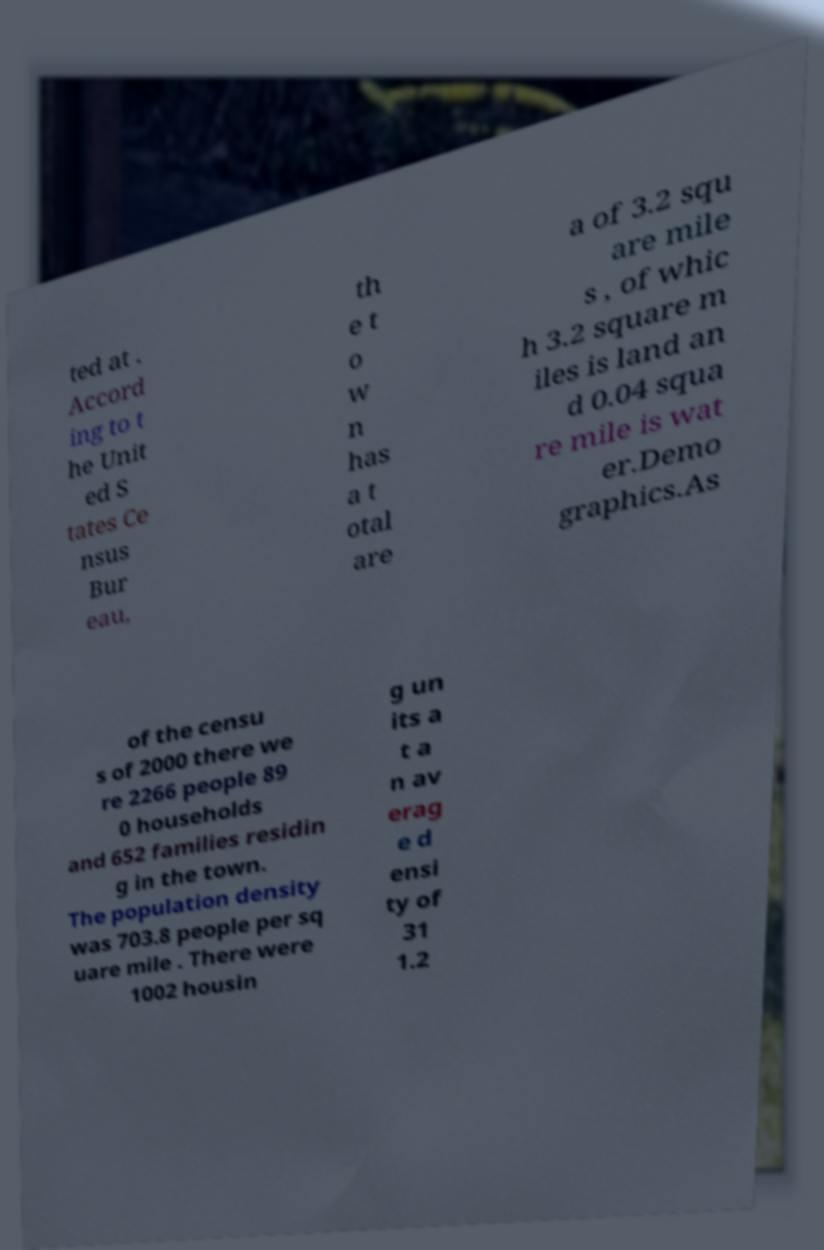For documentation purposes, I need the text within this image transcribed. Could you provide that? ted at . Accord ing to t he Unit ed S tates Ce nsus Bur eau, th e t o w n has a t otal are a of 3.2 squ are mile s , of whic h 3.2 square m iles is land an d 0.04 squa re mile is wat er.Demo graphics.As of the censu s of 2000 there we re 2266 people 89 0 households and 652 families residin g in the town. The population density was 703.8 people per sq uare mile . There were 1002 housin g un its a t a n av erag e d ensi ty of 31 1.2 